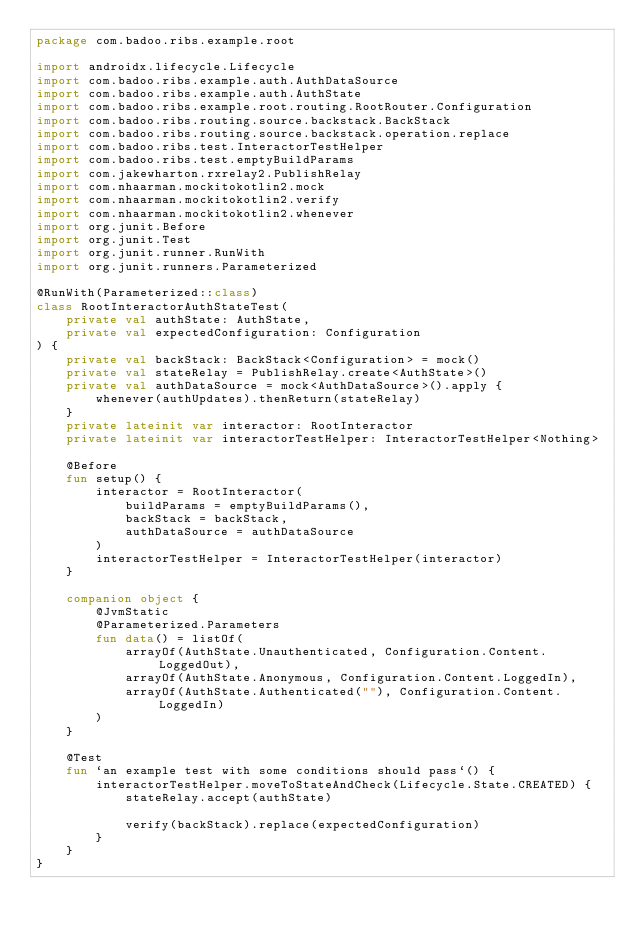Convert code to text. <code><loc_0><loc_0><loc_500><loc_500><_Kotlin_>package com.badoo.ribs.example.root

import androidx.lifecycle.Lifecycle
import com.badoo.ribs.example.auth.AuthDataSource
import com.badoo.ribs.example.auth.AuthState
import com.badoo.ribs.example.root.routing.RootRouter.Configuration
import com.badoo.ribs.routing.source.backstack.BackStack
import com.badoo.ribs.routing.source.backstack.operation.replace
import com.badoo.ribs.test.InteractorTestHelper
import com.badoo.ribs.test.emptyBuildParams
import com.jakewharton.rxrelay2.PublishRelay
import com.nhaarman.mockitokotlin2.mock
import com.nhaarman.mockitokotlin2.verify
import com.nhaarman.mockitokotlin2.whenever
import org.junit.Before
import org.junit.Test
import org.junit.runner.RunWith
import org.junit.runners.Parameterized

@RunWith(Parameterized::class)
class RootInteractorAuthStateTest(
    private val authState: AuthState,
    private val expectedConfiguration: Configuration
) {
    private val backStack: BackStack<Configuration> = mock()
    private val stateRelay = PublishRelay.create<AuthState>()
    private val authDataSource = mock<AuthDataSource>().apply {
        whenever(authUpdates).thenReturn(stateRelay)
    }
    private lateinit var interactor: RootInteractor
    private lateinit var interactorTestHelper: InteractorTestHelper<Nothing>

    @Before
    fun setup() {
        interactor = RootInteractor(
            buildParams = emptyBuildParams(),
            backStack = backStack,
            authDataSource = authDataSource
        )
        interactorTestHelper = InteractorTestHelper(interactor)
    }

    companion object {
        @JvmStatic
        @Parameterized.Parameters
        fun data() = listOf(
            arrayOf(AuthState.Unauthenticated, Configuration.Content.LoggedOut),
            arrayOf(AuthState.Anonymous, Configuration.Content.LoggedIn),
            arrayOf(AuthState.Authenticated(""), Configuration.Content.LoggedIn)
        )
    }

    @Test
    fun `an example test with some conditions should pass`() {
        interactorTestHelper.moveToStateAndCheck(Lifecycle.State.CREATED) {
            stateRelay.accept(authState)

            verify(backStack).replace(expectedConfiguration)
        }
    }
}
</code> 